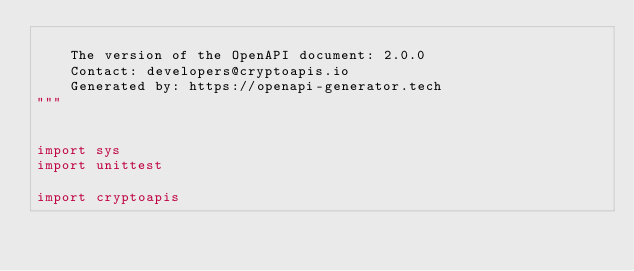Convert code to text. <code><loc_0><loc_0><loc_500><loc_500><_Python_>
    The version of the OpenAPI document: 2.0.0
    Contact: developers@cryptoapis.io
    Generated by: https://openapi-generator.tech
"""


import sys
import unittest

import cryptoapis</code> 